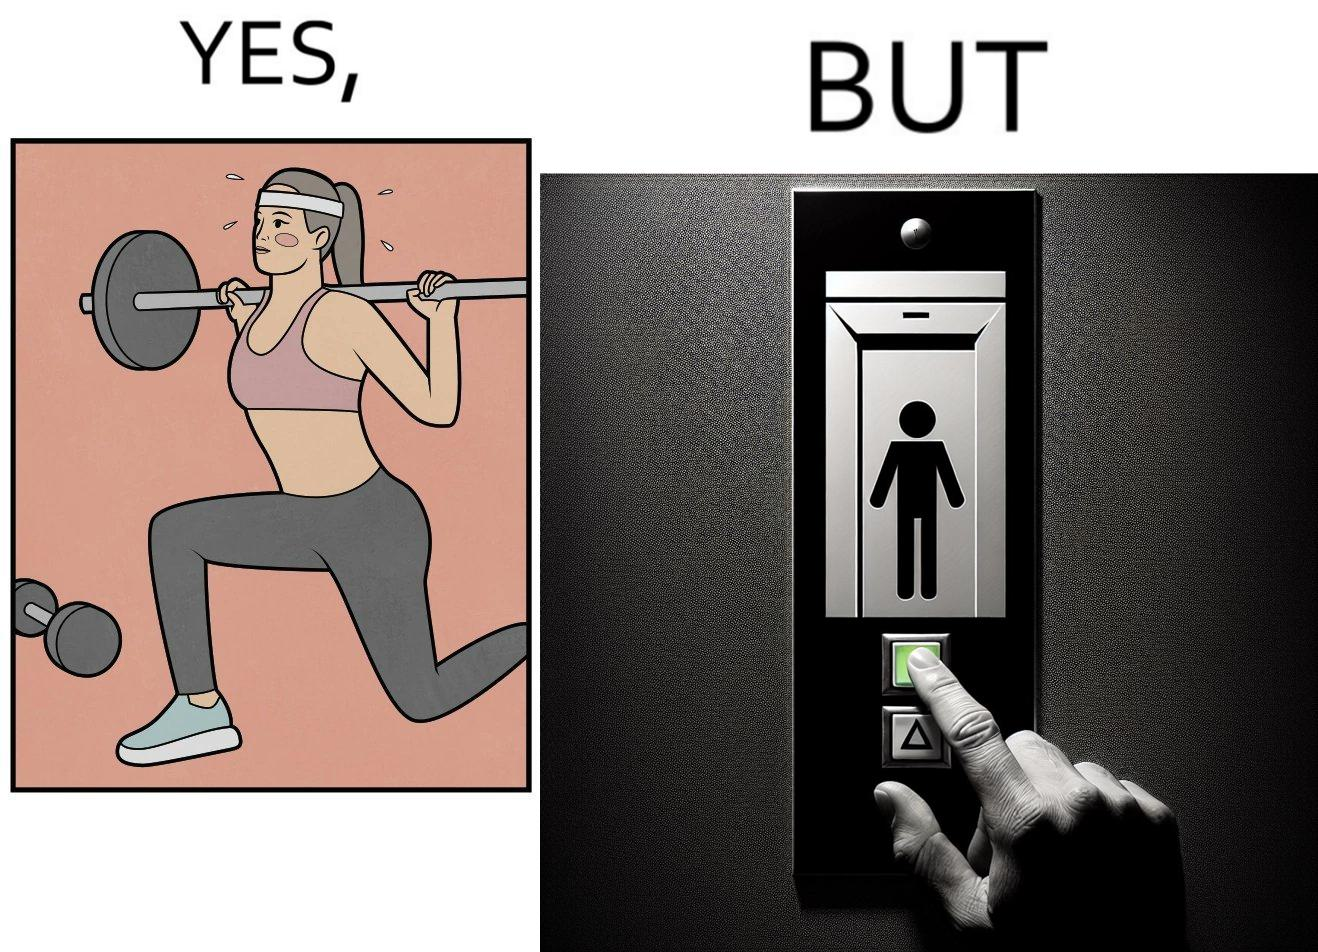Does this image contain satire or humor? Yes, this image is satirical. 